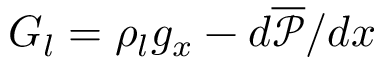Convert formula to latex. <formula><loc_0><loc_0><loc_500><loc_500>G _ { l } = \rho _ { l } g _ { x } - d \overline { { \mathcal { P } } } / d x</formula> 